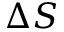Convert formula to latex. <formula><loc_0><loc_0><loc_500><loc_500>\Delta S</formula> 